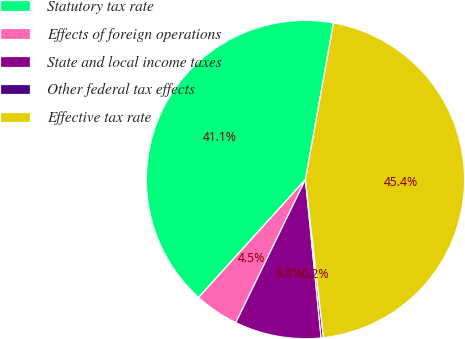Convert chart to OTSL. <chart><loc_0><loc_0><loc_500><loc_500><pie_chart><fcel>Statutory tax rate<fcel>Effects of foreign operations<fcel>State and local income taxes<fcel>Other federal tax effects<fcel>Effective tax rate<nl><fcel>41.1%<fcel>4.51%<fcel>8.78%<fcel>0.23%<fcel>45.37%<nl></chart> 